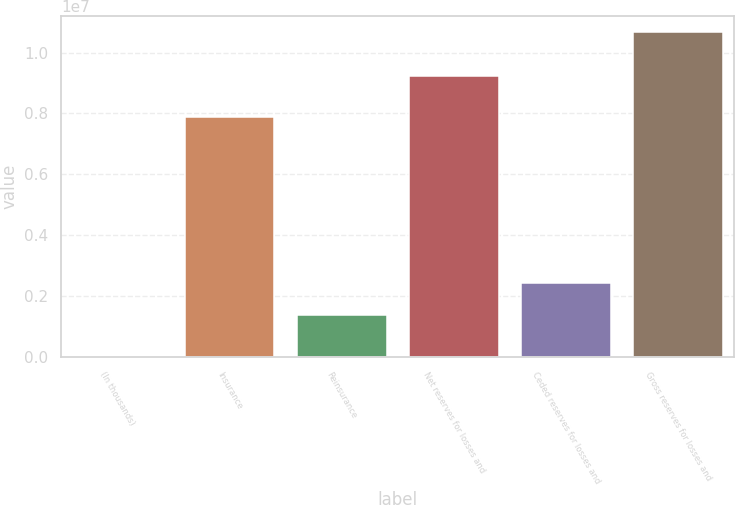Convert chart. <chart><loc_0><loc_0><loc_500><loc_500><bar_chart><fcel>(In thousands)<fcel>Insurance<fcel>Reinsurance<fcel>Net reserves for losses and<fcel>Ceded reserves for losses and<fcel>Gross reserves for losses and<nl><fcel>2015<fcel>7.87619e+06<fcel>1.36868e+06<fcel>9.24487e+06<fcel>2.43539e+06<fcel>1.06692e+07<nl></chart> 